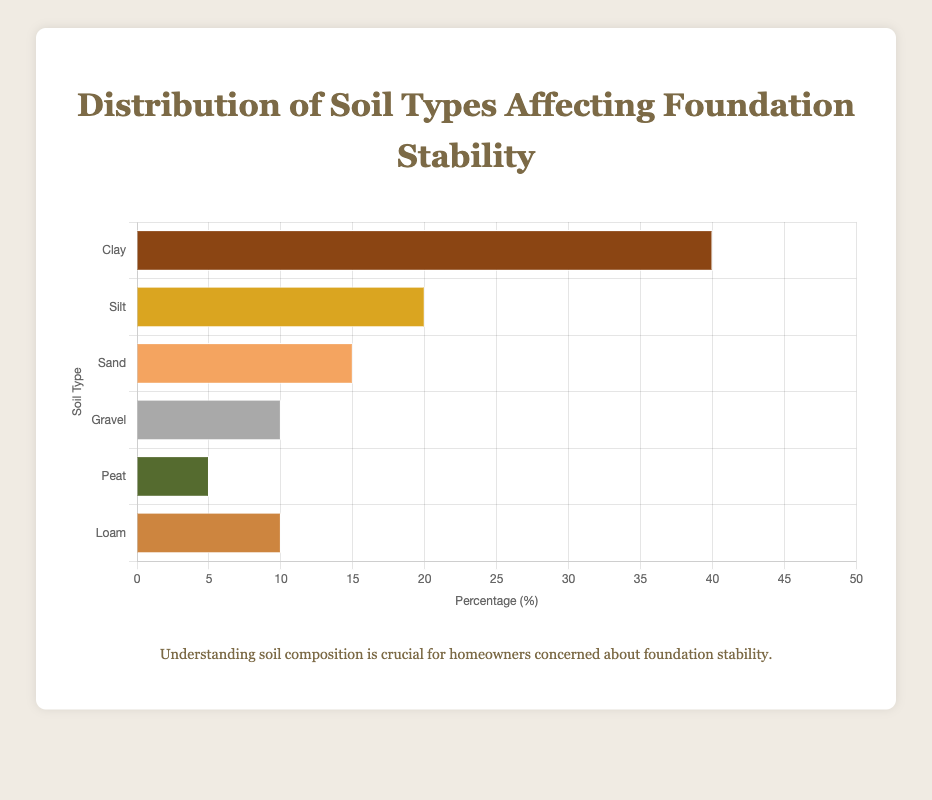What soil type has the highest percentage? The chart shows six soil types and their corresponding percentages. The soil type with the highest percentage bar is "Clay" at 40%.
Answer: Clay Which soil type has a percentage greater than 15%? The chart shows soil types and their percentages; "Clay" at 40% and "Silt" at 20% are greater than 15%.
Answer: Clay and Silt What is the total percentage of Sand, Gravel, and Loam? The percentages for Sand, Gravel, and Loam are 15%, 10%, and 10%, respectively. Summing them up gives 15 + 10 + 10 = 35%.
Answer: 35% How much higher is the percentage of Clay compared to Peat? The percentage of Clay is 40%, and the percentage of Peat is 5%. The difference is 40 - 5 = 35%.
Answer: 35% Which soil type has the shortest bar, and what does it represent? The shortest bar represents the soil type with the lowest percentage. "Peat" has the shortest bar with a percentage of 5%.
Answer: Peat; 5% Is the percentage of Loam the same as the Percentage of Gravel? By observing the chart, both Loam and Gravel have a percentage of 10%.
Answer: Yes What is the sum percentage of Clay and Silt? The percentage of Clay is 40%, and that of Silt is 20%. Summing these gives 40 + 20 = 60%.
Answer: 60% How does the average percentage of Clay, Silt, and Sand compare to 20%? The sum of percentages for Clay, Silt, and Sand is 40 + 20 + 15 = 75%. The average is 75 / 3 = 25%. 25% is greater than 20%.
Answer: Greater What soil types are represented by the brown shades? The brown shades in the chart correspond to the percentages: Clay (brown shade) and Loam (brown shade).
Answer: Clay and Loam 